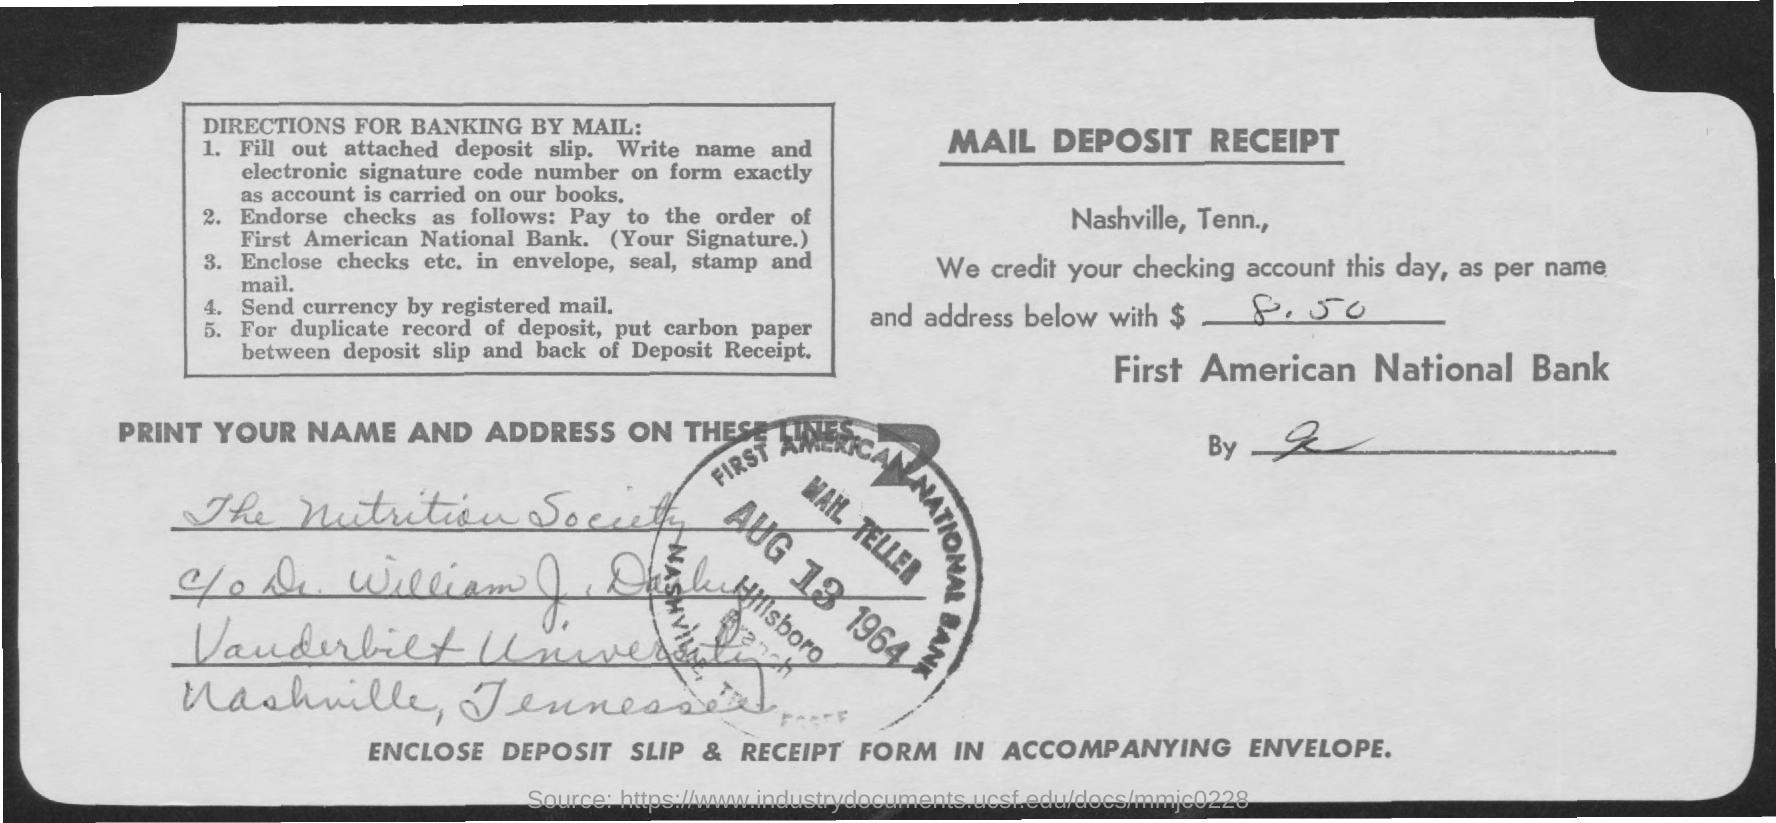What kind of receipt is this?
Ensure brevity in your answer.  Mail deposit receipt. How much amount is credited "as per name and address"?
Keep it short and to the point. $ 8.50. To which bank is amount credited?
Provide a short and direct response. First American National Bank. What is the date on the seal?
Offer a very short reply. AUG 13 1964. Which  "BANK" name  is on the seal?
Give a very brief answer. First American National Bank. Which society's name is mentioned in the address field?
Your answer should be very brief. The nutrition society. Which "university" is mentioned in the "ADDRESS"?
Keep it short and to the point. Vanderbilt university. According to "DIRECTIONS FOR BANKING BY MAIL:"  "currency" has to be send by what type of mail??
Give a very brief answer. Registered. 